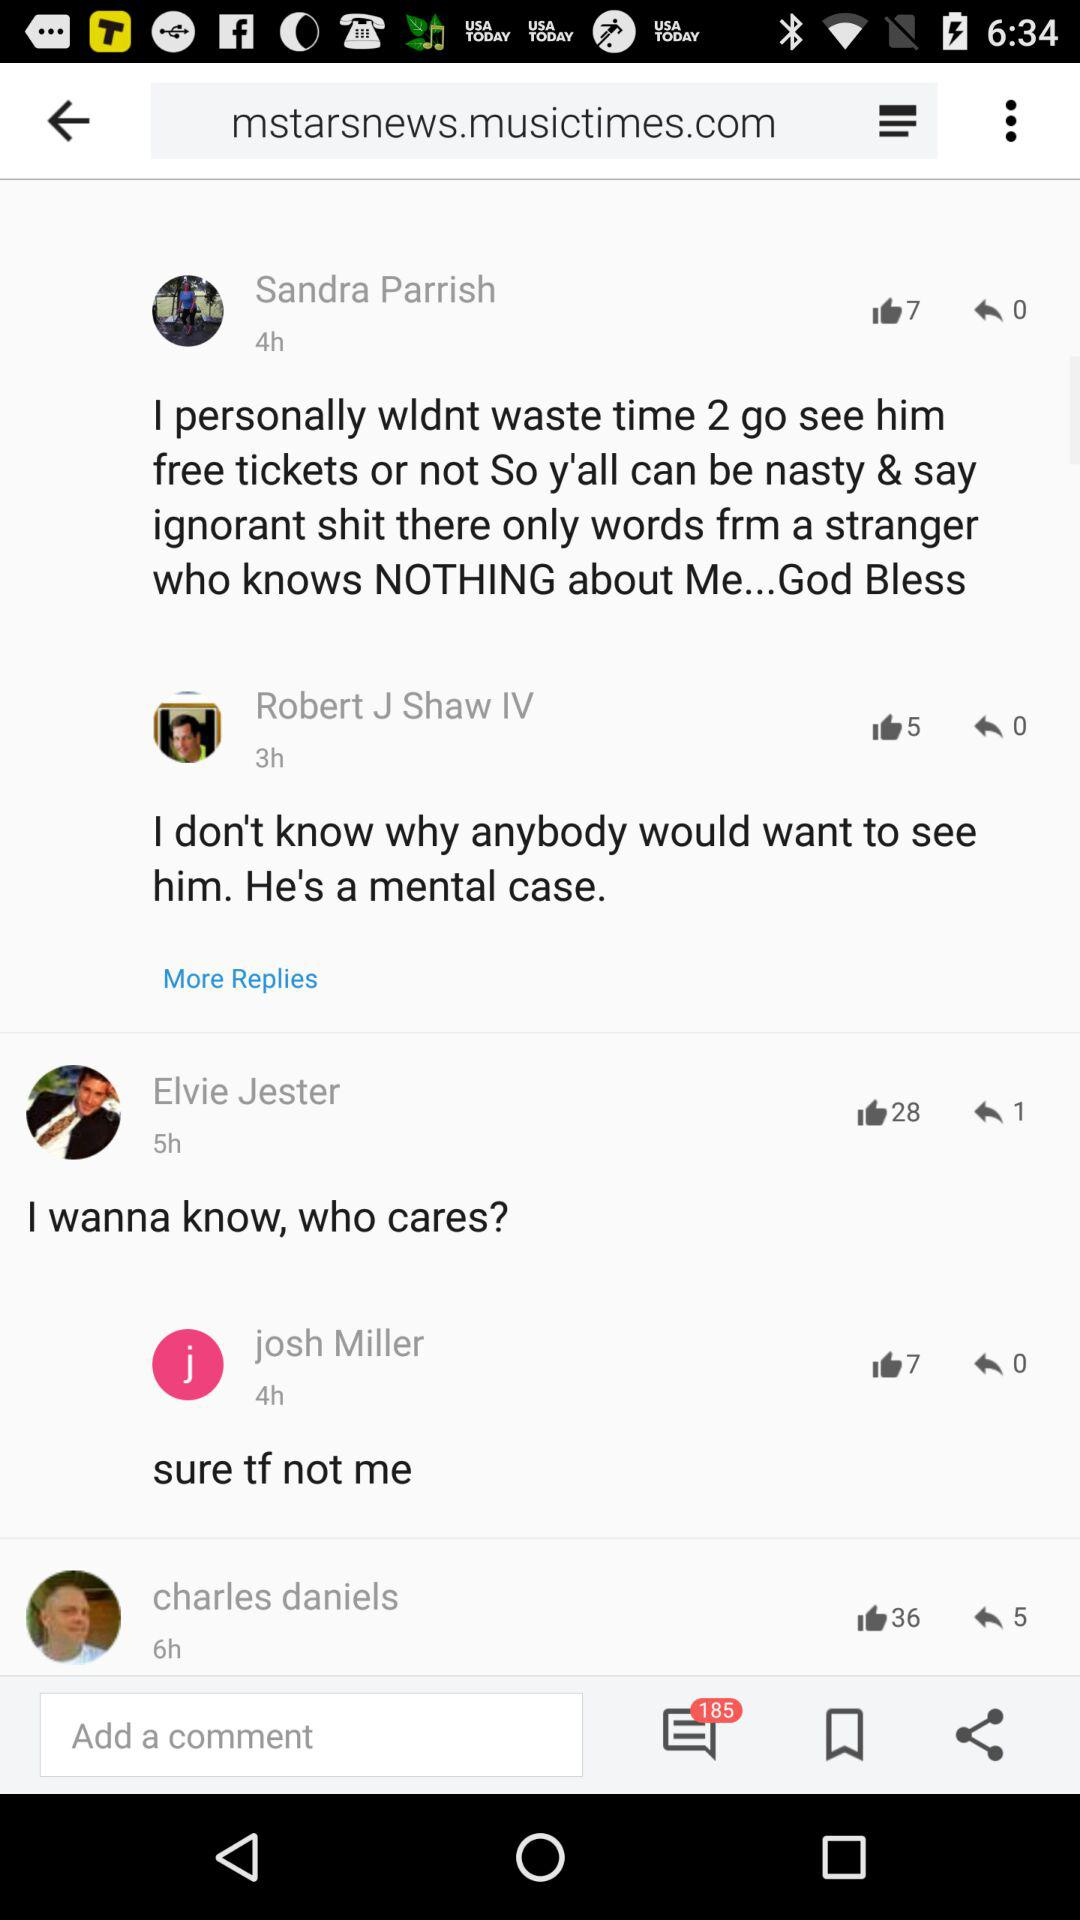How many thumbs up are there for the comment by josh Miller?
Answer the question using a single word or phrase. 7 